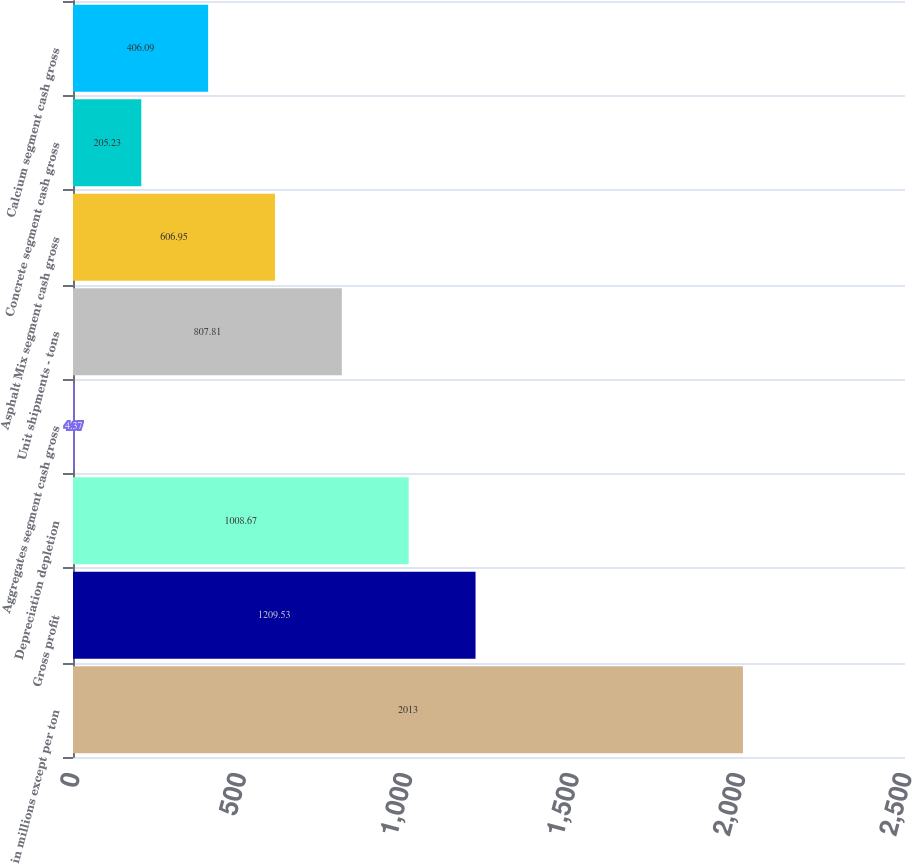Convert chart. <chart><loc_0><loc_0><loc_500><loc_500><bar_chart><fcel>in millions except per ton<fcel>Gross profit<fcel>Depreciation depletion<fcel>Aggregates segment cash gross<fcel>Unit shipments - tons<fcel>Asphalt Mix segment cash gross<fcel>Concrete segment cash gross<fcel>Calcium segment cash gross<nl><fcel>2013<fcel>1209.53<fcel>1008.67<fcel>4.37<fcel>807.81<fcel>606.95<fcel>205.23<fcel>406.09<nl></chart> 